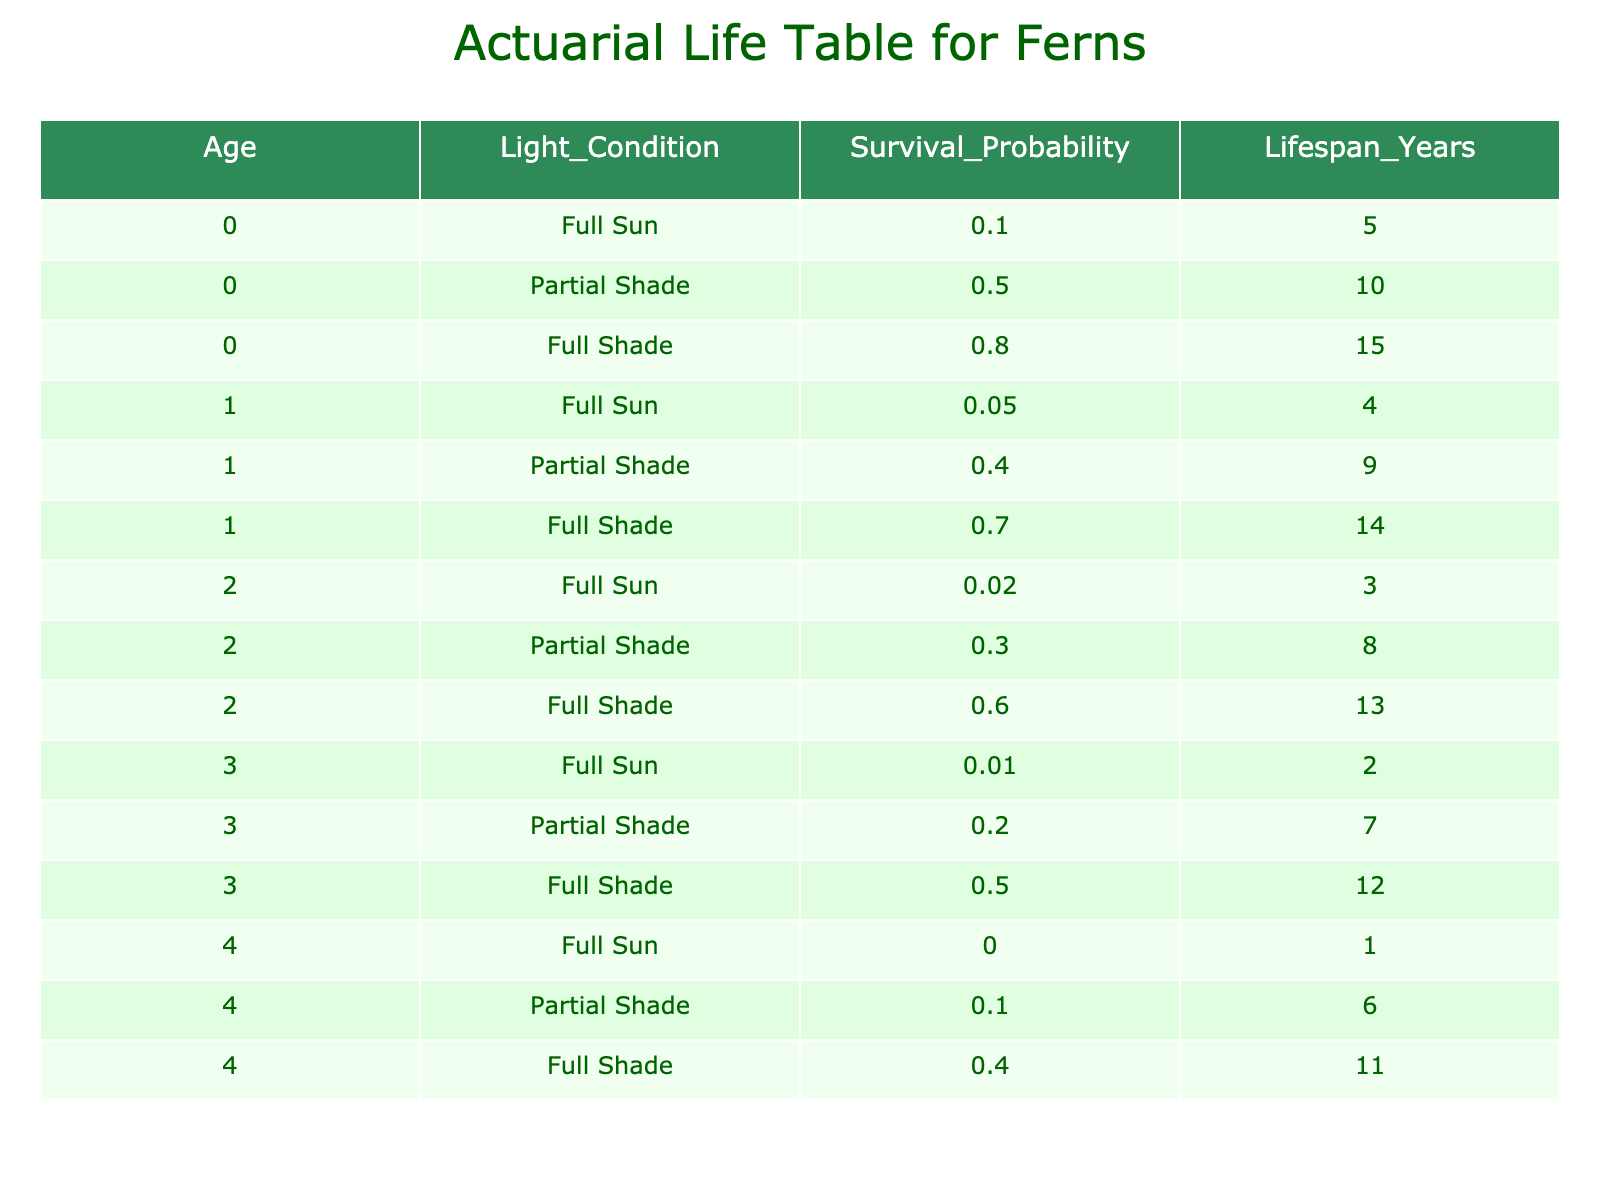What is the survival probability for a fern at age 0 in full shade? The table indicates that for age 0 under full shade conditions, the survival probability is 0.8.
Answer: 0.8 What is the lifespan for a fern at age 1 in partial shade? By the table, we see that the lifespan for a fern at age 1 in partial shade is 9 years.
Answer: 9 years What is the average lifespan of ferns at age 2 across all light conditions? For age 2, the lifespans are 3 (full sun), 8 (partial shade), and 13 (full shade). To find the average: (3 + 8 + 13) / 3 = 24 / 3 = 8.
Answer: 8 years Is the survival probability for a fern at age 3 in full sun greater than that of age 4 in partial shade? The survival probability for age 3 in full sun is 0.01, while for age 4 in partial shade it is 0.1, meaning 0.01 < 0.1, thus the statement is false.
Answer: No What is the total lifespan of ferns at age 0 in all light conditions combined? The lifespans at age 0 are 5 (full sun), 10 (partial shade), and 15 (full shade). Thus, the total lifespan is 5 + 10 + 15 = 30.
Answer: 30 years At age 2, does full shade provide the highest survival probability compared to the other light conditions? For age 2, the survival probabilities are 0.02 (full sun), 0.3 (partial shade), and 0.6 (full shade). Among these, 0.6 is the highest, making the statement true.
Answer: Yes What is the difference in survival probability between age 1 in full sun and age 1 in full shade? Age 1 in full sun has a survival probability of 0.05, while it is 0.7 in full shade. The difference is 0.7 - 0.05 = 0.65.
Answer: 0.65 What is the highest lifespan recorded in the table and for which light condition and age does it occur? The longest lifespan recorded is 15 years which occurs at age 0 in full shade.
Answer: 15 years in full shade at age 0 What is the total survival probability for a fern at age 4 across all light conditions? The survival probabilities for age 4 are 0 (full sun), 0.1 (partial shade), and 0.4 (full shade). Adding these gives 0 + 0.1 + 0.4 = 0.5.
Answer: 0.5 